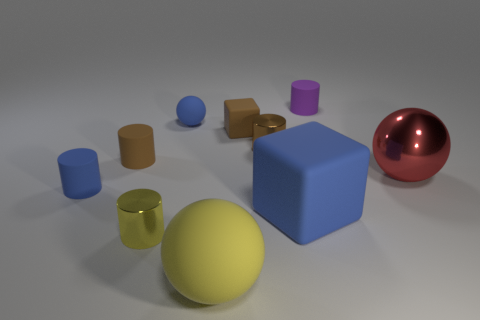Subtract all yellow metal cylinders. How many cylinders are left? 4 Subtract all purple cylinders. How many cylinders are left? 4 Subtract all blue cylinders. Subtract all brown cubes. How many cylinders are left? 4 Subtract all blocks. How many objects are left? 8 Add 9 small red shiny balls. How many small red shiny balls exist? 9 Subtract 0 purple spheres. How many objects are left? 10 Subtract all small purple cylinders. Subtract all blue matte things. How many objects are left? 6 Add 6 blue rubber cylinders. How many blue rubber cylinders are left? 7 